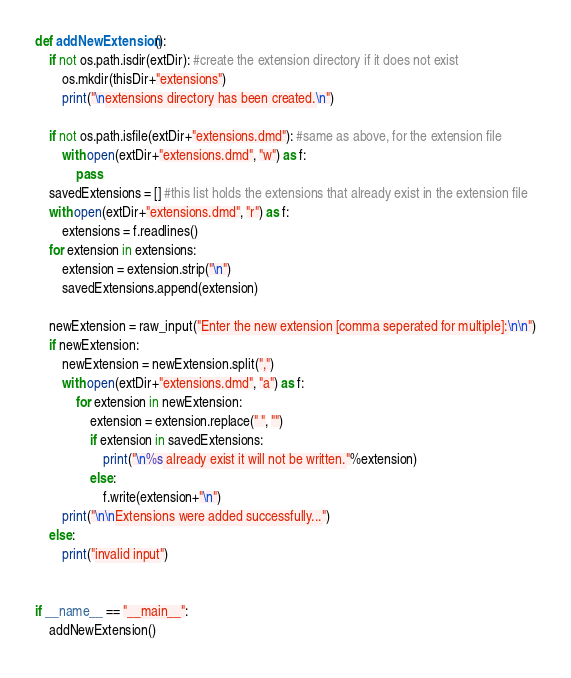<code> <loc_0><loc_0><loc_500><loc_500><_Python_>
def addNewExtension():
    if not os.path.isdir(extDir): #create the extension directory if it does not exist
        os.mkdir(thisDir+"extensions")
        print("\nextensions directory has been created.\n")

    if not os.path.isfile(extDir+"extensions.dmd"): #same as above, for the extension file
        with open(extDir+"extensions.dmd", "w") as f:
            pass
    savedExtensions = [] #this list holds the extensions that already exist in the extension file
    with open(extDir+"extensions.dmd", "r") as f:
        extensions = f.readlines()
    for extension in extensions:
        extension = extension.strip("\n")
        savedExtensions.append(extension)

    newExtension = raw_input("Enter the new extension [comma seperated for multiple]:\n\n")
    if newExtension:
        newExtension = newExtension.split(",")
        with open(extDir+"extensions.dmd", "a") as f:
            for extension in newExtension:
                extension = extension.replace(" ", "")
                if extension in savedExtensions:
                    print("\n%s already exist it will not be written."%extension)
                else:
                    f.write(extension+"\n")
        print("\n\nExtensions were added successfully...")
    else:
        print("invalid input")


if __name__ == "__main__":
    addNewExtension()
</code> 